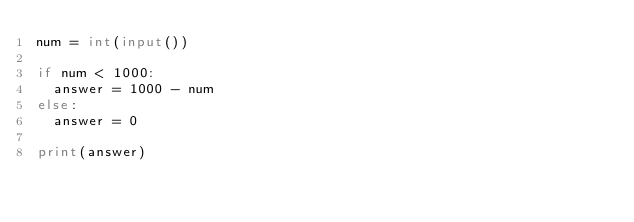Convert code to text. <code><loc_0><loc_0><loc_500><loc_500><_Python_>num = int(input())

if num < 1000:
  answer = 1000 - num
else:
  answer = 0

print(answer)</code> 